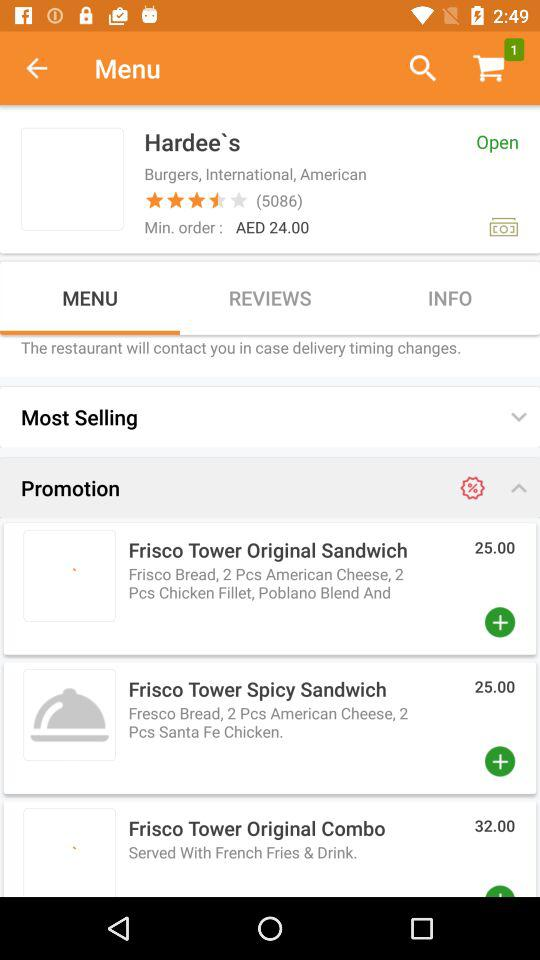What is the number of reviews? The number of reviews is 5086. 